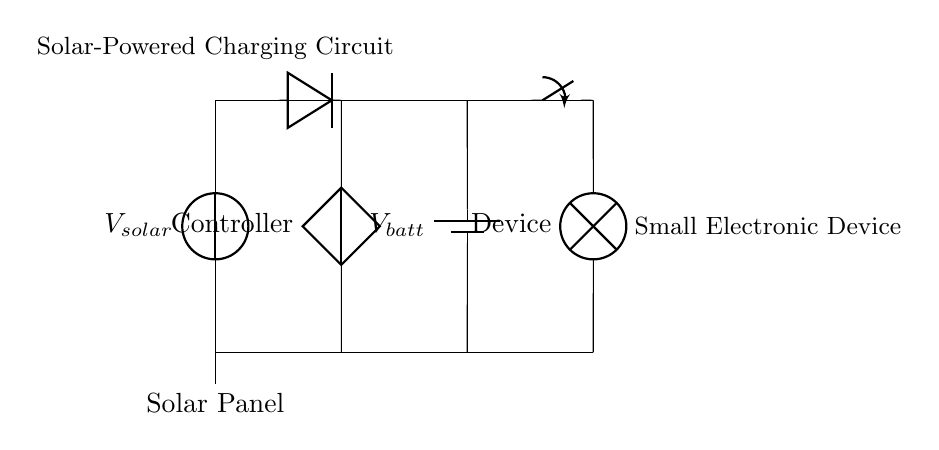What type of solar energy device is depicted in the circuit? The circuit shows a solar panel at the beginning, generating electricity from sunlight. A solar panel is specifically designed to convert solar energy into electrical energy.
Answer: solar panel What component is used for reverse current protection? The circuit includes a diode, which is connected in such a way that it allows current to flow in one direction only, preventing any reverse current flow, which could damage other components.
Answer: diode What is the voltage source connected to the battery labeled? The battery is labeled as V_batt, which represents the voltage across the battery. In this circuit, it indicates the energy stored in the battery that can be used to power the device.
Answer: V_batt How many main components are there in this solar-powered charging circuit? The primary components visible in the diagram include a solar panel, a charging controller, a battery, and a small electronic device, making a total of four main components linked within the circuit.
Answer: four What purpose does the switch serve in the circuit? The switch is placed between the battery and the small electronic device, allowing the user to control the flow of current to the device. By opening or closing the switch, the user can turn the device on or off.
Answer: control flow What is the role of the charging controller? The charging controller manages the voltage and current from the solar panel to the battery, ensuring that the battery is charged correctly without overcharging or damaging it.
Answer: manage charging 